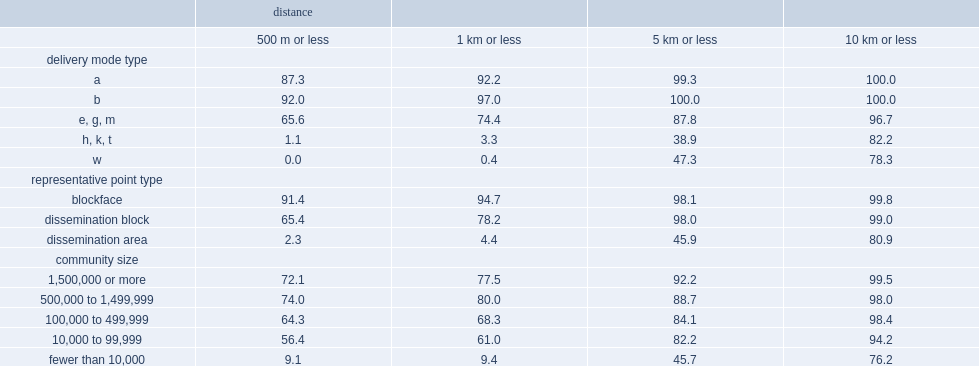What were the percentages of ordinary households (dmt a),large apartment buildings (dmt b) and businesses or institutions (dmt e, g, m) geocoded to within 500 m of their full street address? 87.3 92.0 65.6. What were the percentages of rural postal codes (dmt w) and mixed urban and rural postal codes (dmt h, k, t) geocoded to within 5 km of their residence? 47.3 38.9. What were the percentages of blockface and dissemination block geocoded to within 500 m of their full street address? 91.4 65.4. What was the percentage of dissemination area representative points geocoded to within 5 km of their residence? 45.9. What was the percentage of communities of 10,000 to 99,999 population geocoded to within 500 m of their full street address? 56.4. What was the percentage of rural areas and small towns geocoded to within 5 km of their residence? 45.7. 